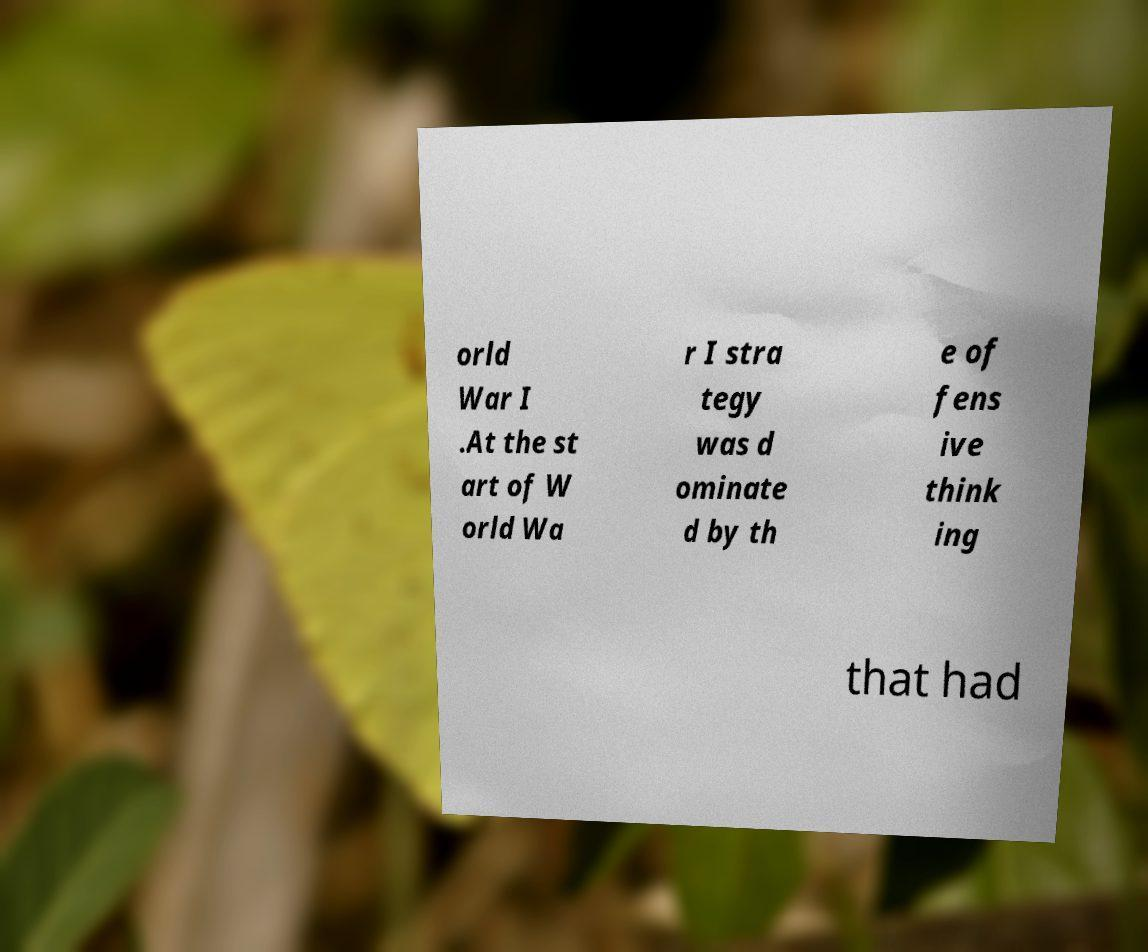Can you accurately transcribe the text from the provided image for me? orld War I .At the st art of W orld Wa r I stra tegy was d ominate d by th e of fens ive think ing that had 